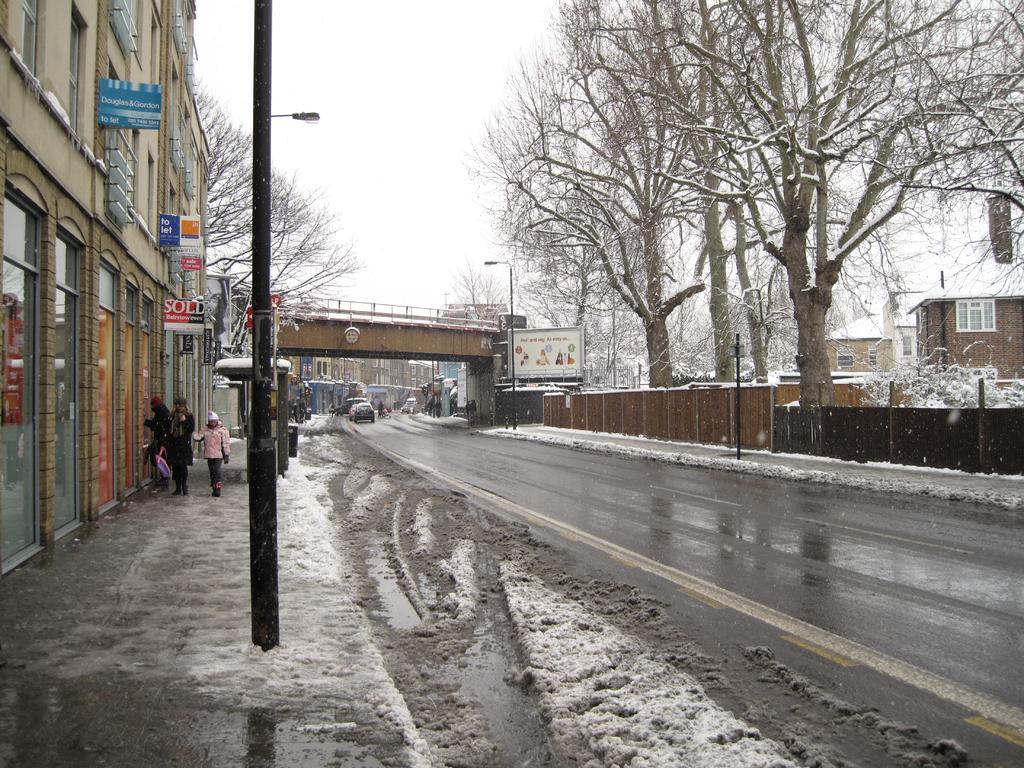Describe this image in one or two sentences. This image consists of a road. To the left, there is snow and there are building along with poles. In the middle, there is a bridge. To the right, there are trees and fencing. 